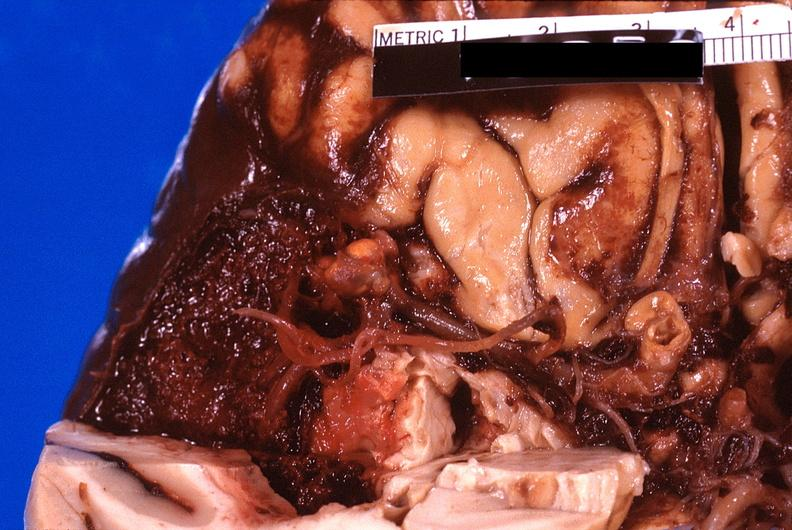s this present?
Answer the question using a single word or phrase. No 